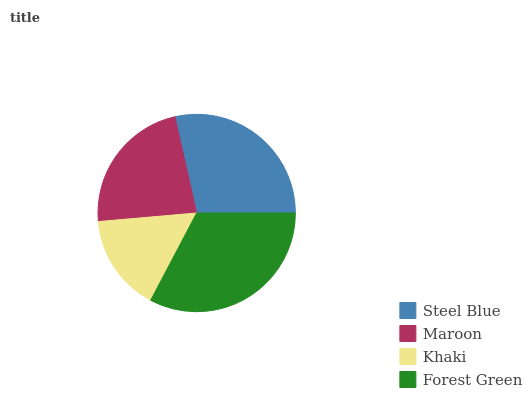Is Khaki the minimum?
Answer yes or no. Yes. Is Forest Green the maximum?
Answer yes or no. Yes. Is Maroon the minimum?
Answer yes or no. No. Is Maroon the maximum?
Answer yes or no. No. Is Steel Blue greater than Maroon?
Answer yes or no. Yes. Is Maroon less than Steel Blue?
Answer yes or no. Yes. Is Maroon greater than Steel Blue?
Answer yes or no. No. Is Steel Blue less than Maroon?
Answer yes or no. No. Is Steel Blue the high median?
Answer yes or no. Yes. Is Maroon the low median?
Answer yes or no. Yes. Is Forest Green the high median?
Answer yes or no. No. Is Khaki the low median?
Answer yes or no. No. 